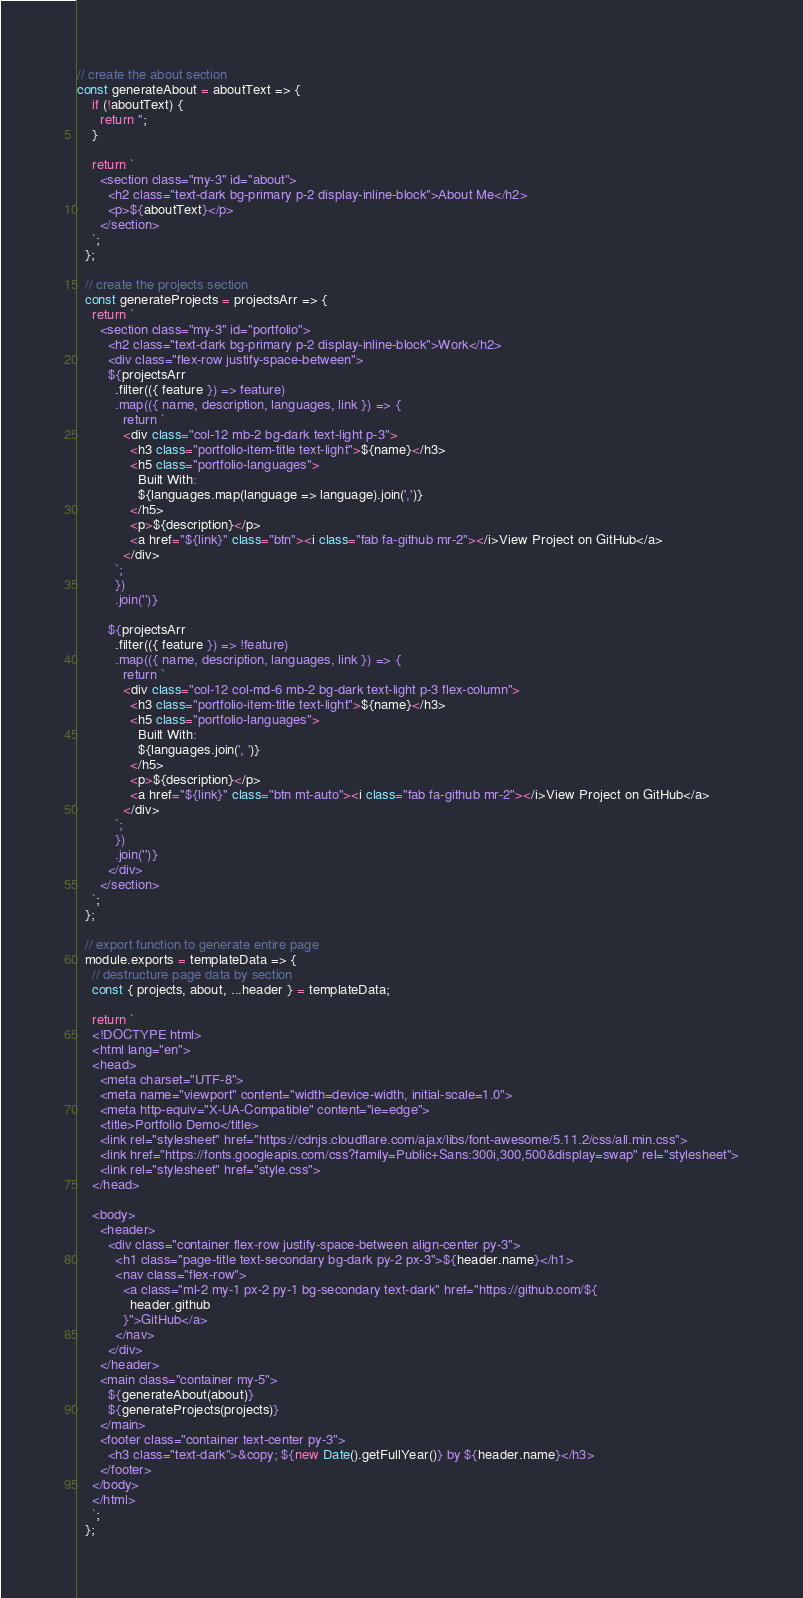<code> <loc_0><loc_0><loc_500><loc_500><_JavaScript_>// create the about section
const generateAbout = aboutText => {
    if (!aboutText) {
      return '';
    }
  
    return `
      <section class="my-3" id="about">
        <h2 class="text-dark bg-primary p-2 display-inline-block">About Me</h2>
        <p>${aboutText}</p>
      </section>
    `;
  };
  
  // create the projects section
  const generateProjects = projectsArr => {
    return `
      <section class="my-3" id="portfolio">
        <h2 class="text-dark bg-primary p-2 display-inline-block">Work</h2>
        <div class="flex-row justify-space-between">
        ${projectsArr
          .filter(({ feature }) => feature)
          .map(({ name, description, languages, link }) => {
            return `
            <div class="col-12 mb-2 bg-dark text-light p-3">
              <h3 class="portfolio-item-title text-light">${name}</h3>
              <h5 class="portfolio-languages">
                Built With:
                ${languages.map(language => language).join(',')}
              </h5>
              <p>${description}</p>
              <a href="${link}" class="btn"><i class="fab fa-github mr-2"></i>View Project on GitHub</a>
            </div>
          `;
          })
          .join('')}
  
        ${projectsArr
          .filter(({ feature }) => !feature)
          .map(({ name, description, languages, link }) => {
            return `
            <div class="col-12 col-md-6 mb-2 bg-dark text-light p-3 flex-column">
              <h3 class="portfolio-item-title text-light">${name}</h3>
              <h5 class="portfolio-languages">
                Built With:
                ${languages.join(', ')}
              </h5>
              <p>${description}</p>
              <a href="${link}" class="btn mt-auto"><i class="fab fa-github mr-2"></i>View Project on GitHub</a>
            </div>
          `;
          })
          .join('')}
        </div>
      </section>
    `;
  };
  
  // export function to generate entire page
  module.exports = templateData => {
    // destructure page data by section
    const { projects, about, ...header } = templateData;
  
    return `
    <!DOCTYPE html>
    <html lang="en">
    <head>
      <meta charset="UTF-8">
      <meta name="viewport" content="width=device-width, initial-scale=1.0">
      <meta http-equiv="X-UA-Compatible" content="ie=edge">
      <title>Portfolio Demo</title>
      <link rel="stylesheet" href="https://cdnjs.cloudflare.com/ajax/libs/font-awesome/5.11.2/css/all.min.css">
      <link href="https://fonts.googleapis.com/css?family=Public+Sans:300i,300,500&display=swap" rel="stylesheet">
      <link rel="stylesheet" href="style.css">
    </head>
    
    <body>
      <header>
        <div class="container flex-row justify-space-between align-center py-3">
          <h1 class="page-title text-secondary bg-dark py-2 px-3">${header.name}</h1>
          <nav class="flex-row">
            <a class="ml-2 my-1 px-2 py-1 bg-secondary text-dark" href="https://github.com/${
              header.github
            }">GitHub</a>
          </nav>
        </div>
      </header>
      <main class="container my-5">
        ${generateAbout(about)}
        ${generateProjects(projects)}
      </main>
      <footer class="container text-center py-3">
        <h3 class="text-dark">&copy; ${new Date().getFullYear()} by ${header.name}</h3>
      </footer>
    </body>
    </html>
    `;
  };</code> 